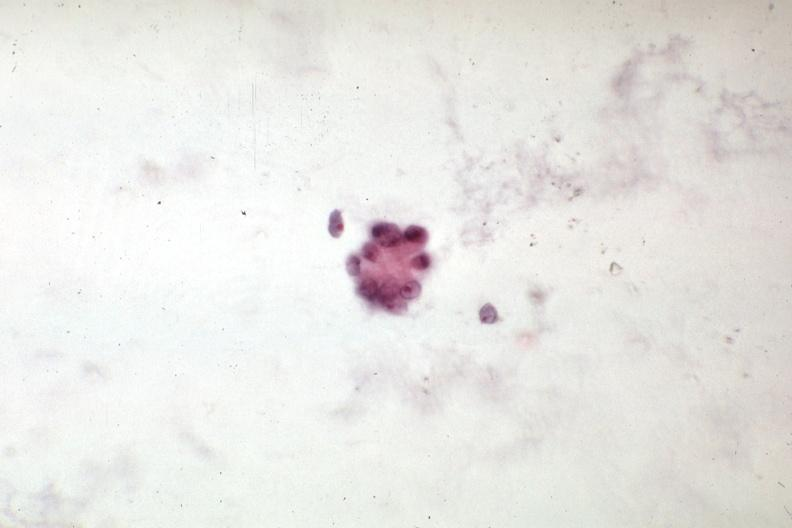does situs inversus show malignant cells mixed mesodermal tumor of uterus?
Answer the question using a single word or phrase. No 